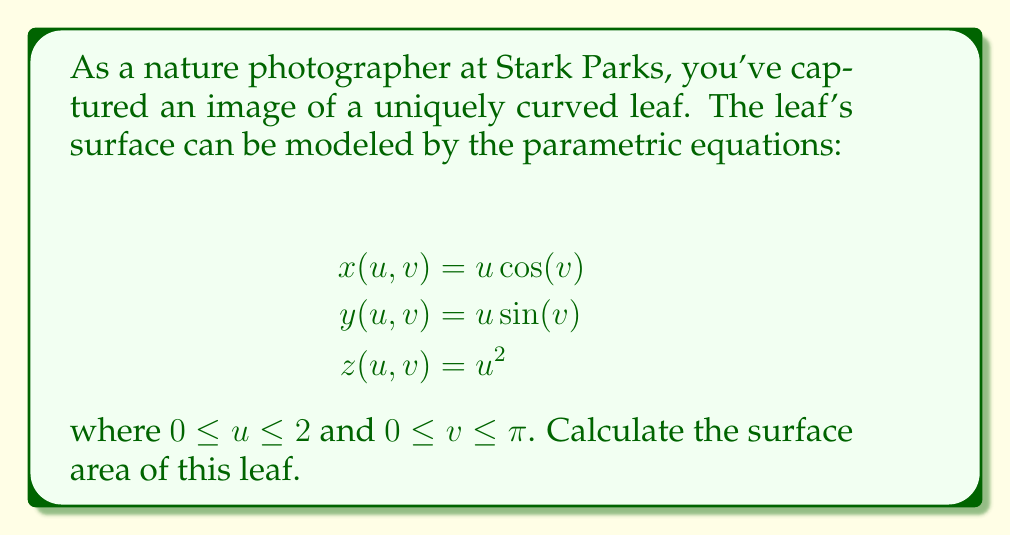Teach me how to tackle this problem. To find the surface area, we need to use the surface integral formula:

$$\text{Surface Area} = \int\int_S \sqrt{EG - F^2} \, du \, dv$$

Where $E$, $F$, and $G$ are the coefficients of the first fundamental form:

$$E = \left(\frac{\partial x}{\partial u}\right)^2 + \left(\frac{\partial y}{\partial u}\right)^2 + \left(\frac{\partial z}{\partial u}\right)^2$$
$$F = \frac{\partial x}{\partial u}\frac{\partial x}{\partial v} + \frac{\partial y}{\partial u}\frac{\partial y}{\partial v} + \frac{\partial z}{\partial u}\frac{\partial z}{\partial v}$$
$$G = \left(\frac{\partial x}{\partial v}\right)^2 + \left(\frac{\partial y}{\partial v}\right)^2 + \left(\frac{\partial z}{\partial v}\right)^2$$

Step 1: Calculate partial derivatives
$$\frac{\partial x}{\partial u} = \cos(v), \frac{\partial x}{\partial v} = -u\sin(v)$$
$$\frac{\partial y}{\partial u} = \sin(v), \frac{\partial y}{\partial v} = u\cos(v)$$
$$\frac{\partial z}{\partial u} = 2u, \frac{\partial z}{\partial v} = 0$$

Step 2: Calculate $E$, $F$, and $G$
$$E = \cos^2(v) + \sin^2(v) + 4u^2 = 1 + 4u^2$$
$$F = -u\sin(v)\cos(v) + u\sin(v)\cos(v) + 0 = 0$$
$$G = u^2\sin^2(v) + u^2\cos^2(v) + 0 = u^2$$

Step 3: Calculate $\sqrt{EG - F^2}$
$$\sqrt{EG - F^2} = \sqrt{(1 + 4u^2)u^2 - 0^2} = u\sqrt{1 + 4u^2}$$

Step 4: Set up and evaluate the double integral
$$\text{Surface Area} = \int_0^\pi \int_0^2 u\sqrt{1 + 4u^2} \, du \, dv$$

Step 5: Solve the inner integral
Let $t = 1 + 4u^2$, then $dt = 8u \, du$ and $u \, du = \frac{1}{8} dt$
$$\int_0^2 u\sqrt{1 + 4u^2} \, du = \frac{1}{8} \int_1^{17} \sqrt{t} \, dt = \frac{1}{12} t^{3/2} \bigg|_1^{17} = \frac{1}{12}(17\sqrt{17} - 1)$$

Step 6: Solve the outer integral
$$\text{Surface Area} = \int_0^\pi \frac{1}{12}(17\sqrt{17} - 1) \, dv = \frac{\pi}{12}(17\sqrt{17} - 1)$$
Answer: $\frac{\pi}{12}(17\sqrt{17} - 1)$ square units 